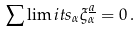Convert formula to latex. <formula><loc_0><loc_0><loc_500><loc_500>\sum \lim i t s _ { \alpha } \xi _ { \alpha } ^ { \underline { a } } = 0 \, .</formula> 